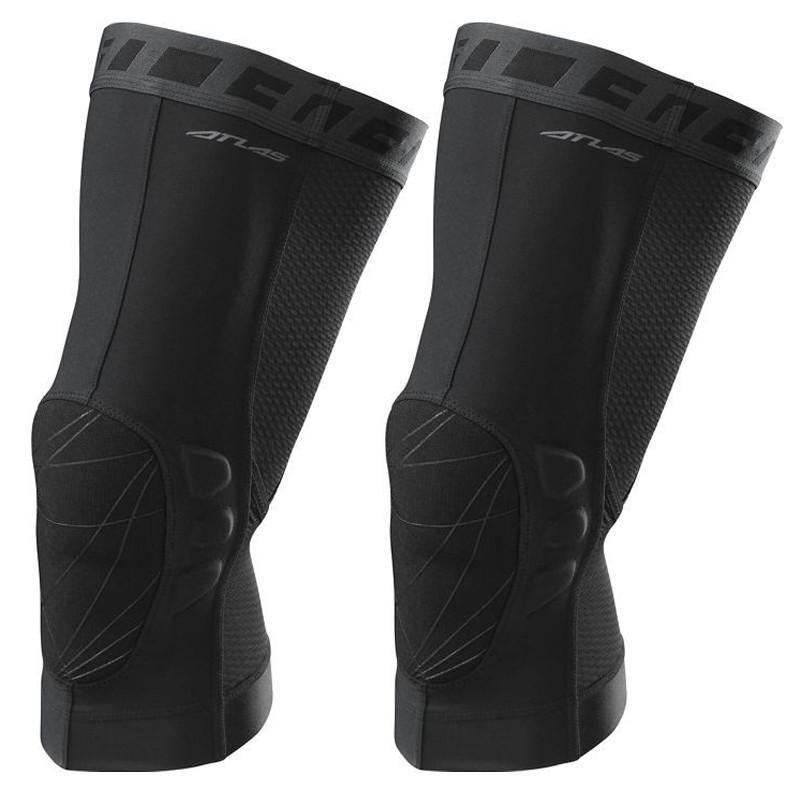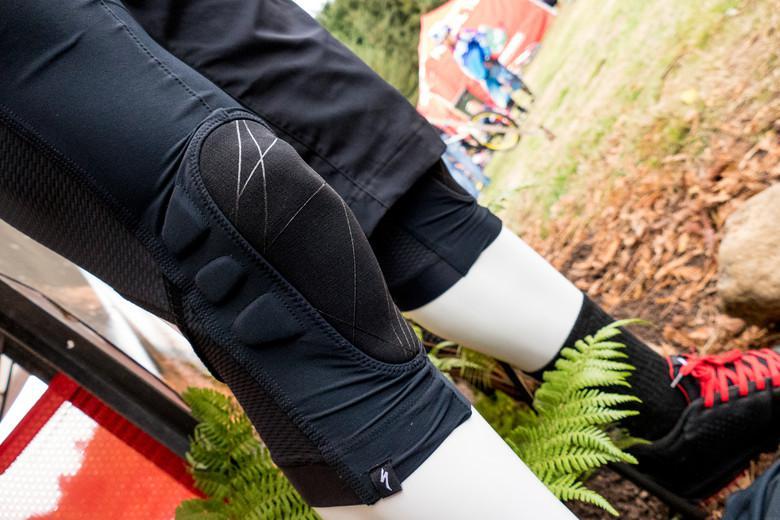The first image is the image on the left, the second image is the image on the right. Assess this claim about the two images: "One of the knees in the image on the left is bent greater than ninety degrees.". Correct or not? Answer yes or no. No. 